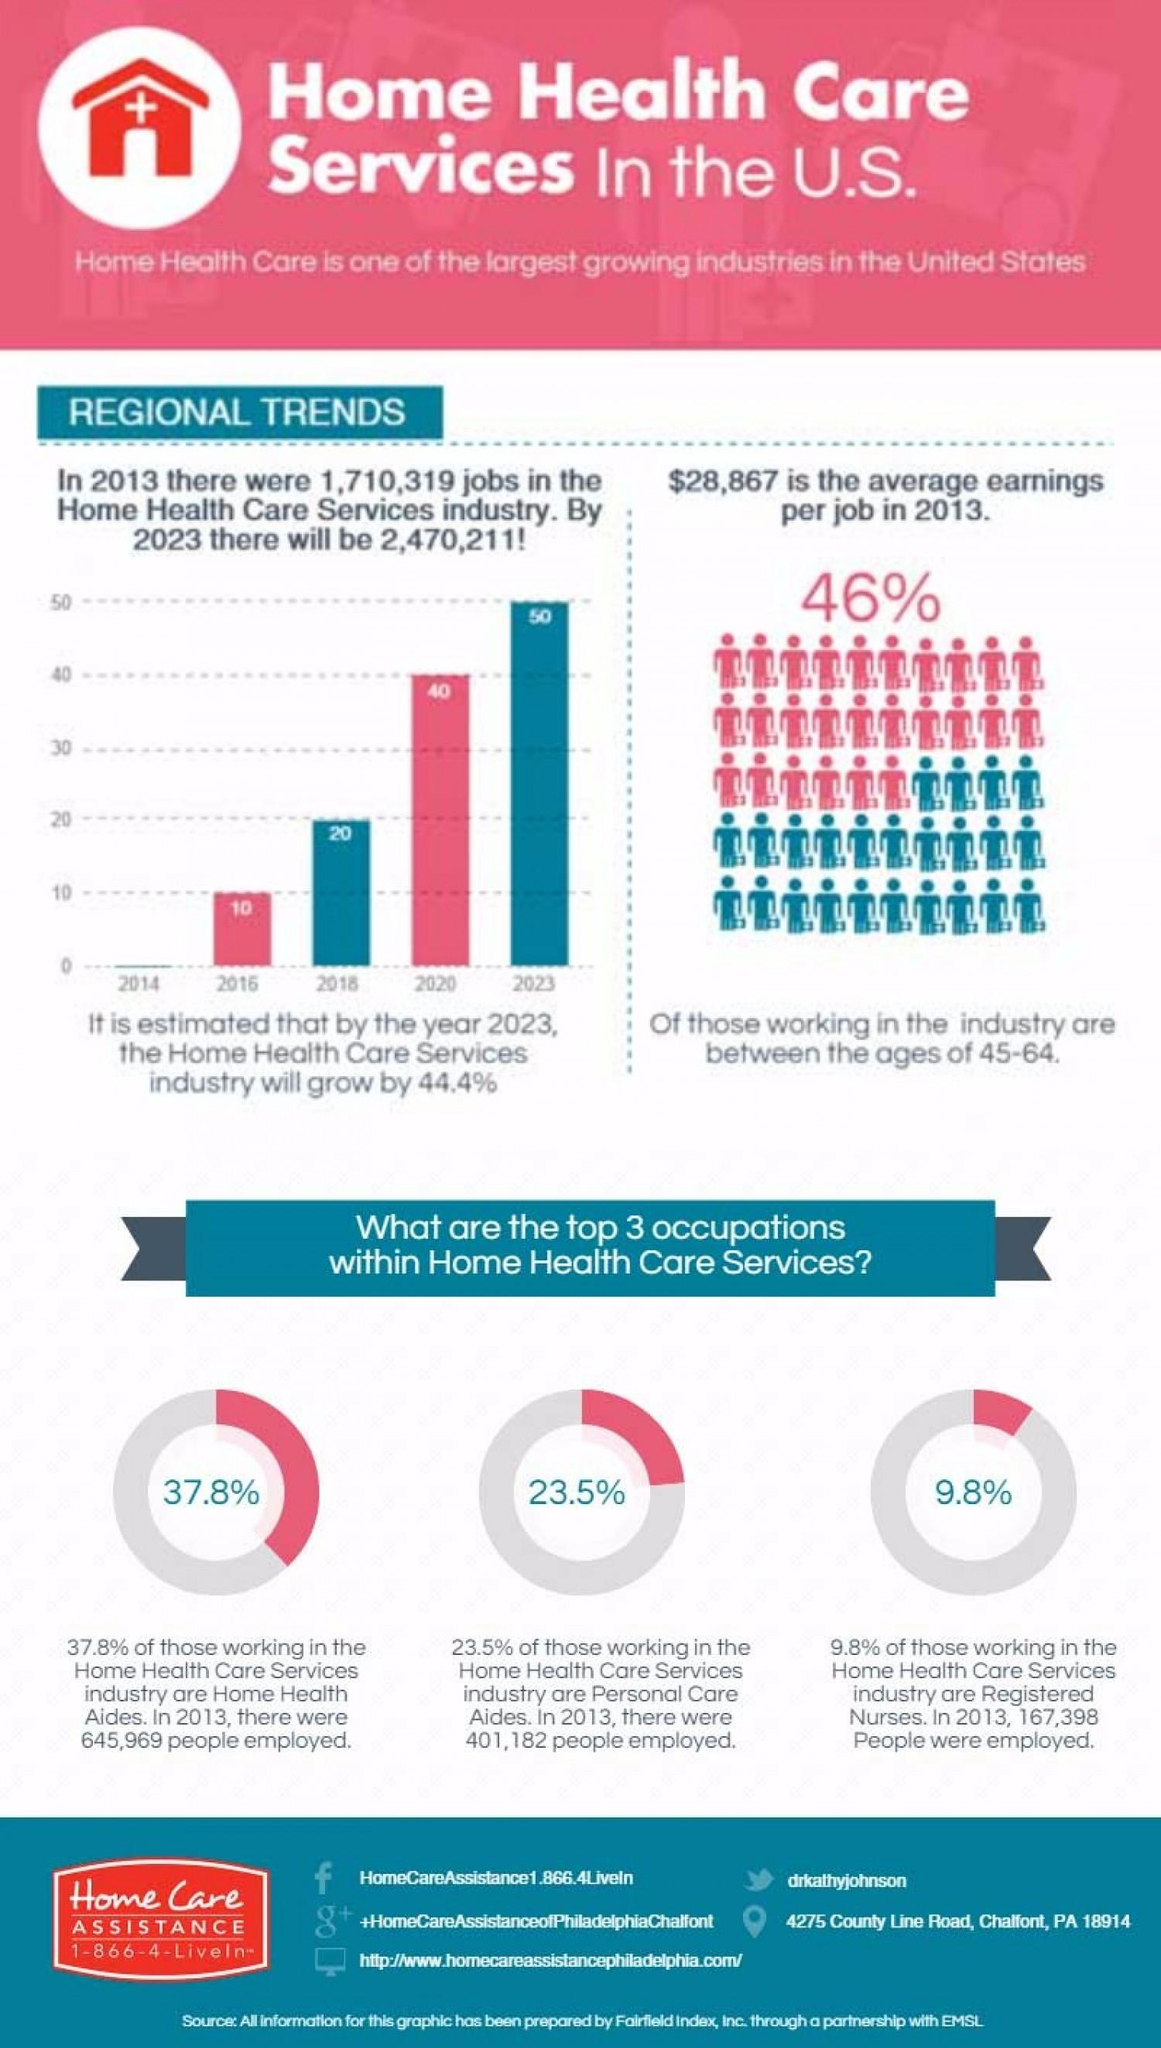Point out several critical features in this image. The Twitter handle for Dr. Kathy Johnson is [insert handle]. Facebook address for HomeCareAssistance is 1.866.454.3546. In 2013, there were 401,182 personal care aides in the United States. Nearly 46% of the population belongs to the age group of 45-64. According to the data, personal care aides make up 23.5% of the healthcare support workforce. 